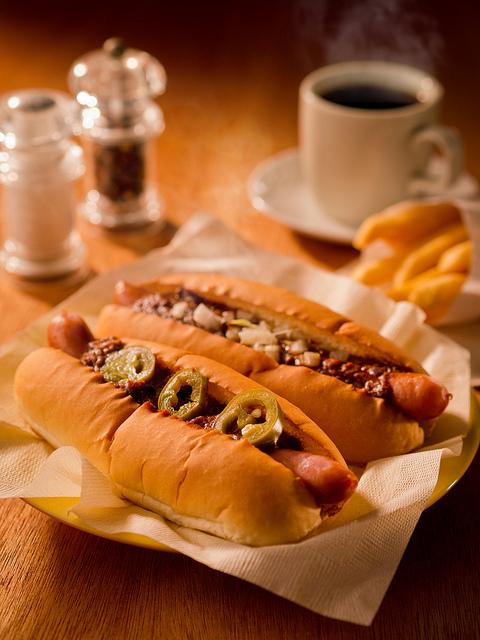Would this be a healthy meal?
Quick response, please. No. Are the hotdogs whole?
Short answer required. Yes. Are condiments on the table?
Answer briefly. Yes. 